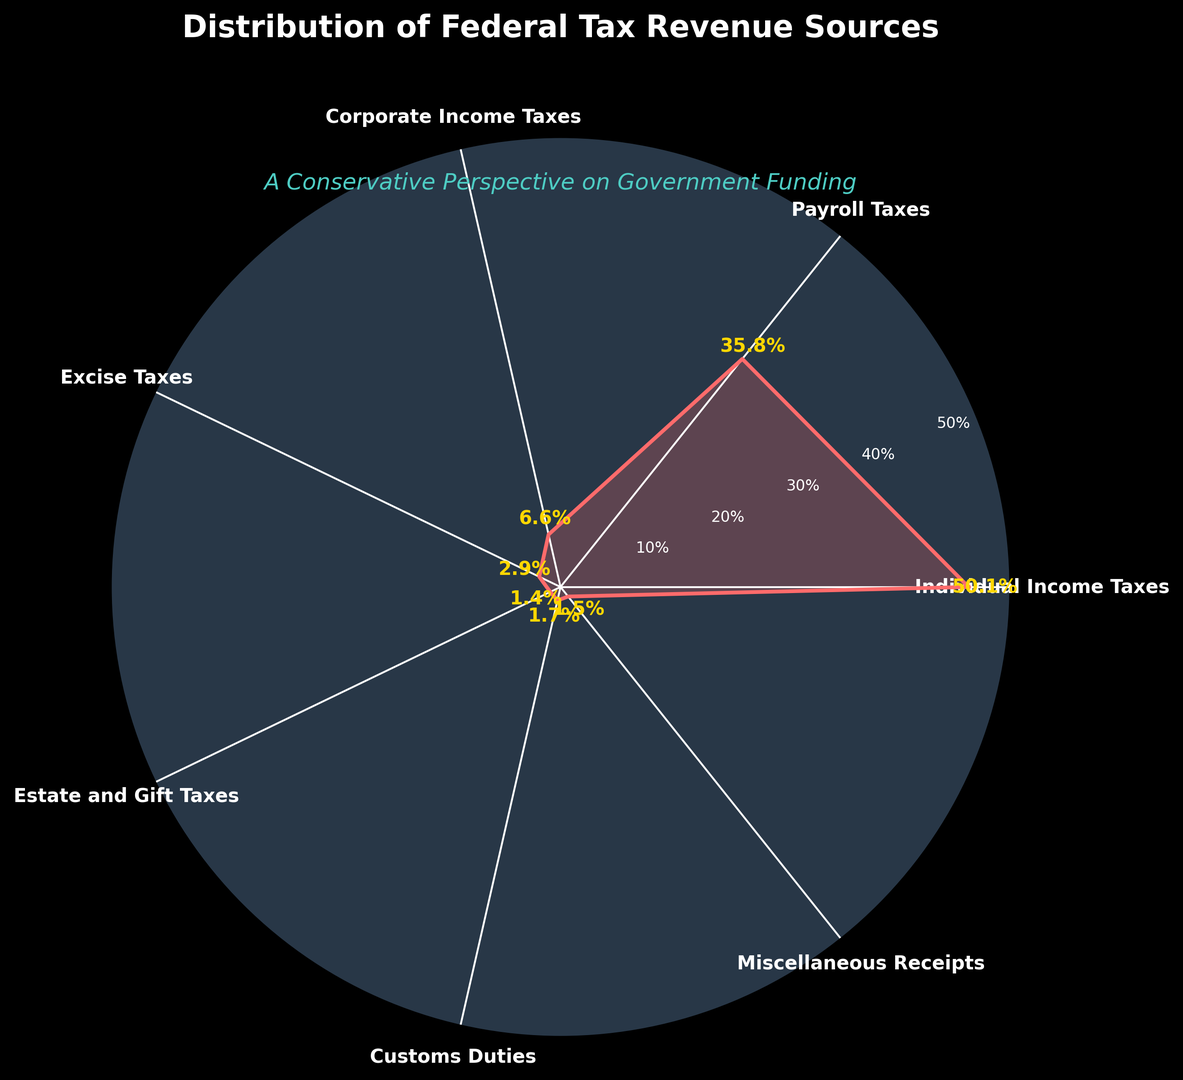What is the primary source of federal tax revenue? By looking at the chart, the section with the largest percentage should be identified as the primary source. The largest percentage is 50.1% which corresponds to Individual Income Taxes.
Answer: Individual Income Taxes Which tax revenue source accounts for a smaller percentage: Corporate Income Taxes or Excise Taxes? The chart shows that Corporate Income Taxes account for 6.6% and Excise Taxes account for 2.9%. Comparing these two, 2.9% is smaller than 6.6%.
Answer: Excise Taxes What is the combined percentage of Payroll Taxes and Customs Duties? According to the chart, Payroll Taxes account for 35.8% and Customs Duties account for 1.7%. Adding these two percentages gives 35.8 + 1.7 = 37.5%.
Answer: 37.5% Which tax revenue source contributes more, Excise Taxes or Miscellaneous Receipts? The chart shows that Excise Taxes contribute 2.9% and Miscellaneous Receipts contribute 1.5%. Comparing these two, 2.9% is greater than 1.5%.
Answer: Excise Taxes What is the sum of the percentages for Estate and Gift Taxes and Corporate Income Taxes? According to the chart, Estate and Gift Taxes account for 1.4% and Corporate Income Taxes account for 6.6%. Adding these two percentages gives 1.4 + 6.6 = 8.0%.
Answer: 8.0% How much more significant is the percentage of Individual Income Taxes compared to Corporate Income Taxes? The chart shows that Individual Income Taxes account for 50.1% and Corporate Income Taxes for 6.6%. The difference is 50.1 - 6.6 = 43.5%.
Answer: 43.5% Which two tax categories together account for almost the same percentage as Individual Income Taxes alone? Individual Income Taxes account for 50.1%. Looking at the chart, Payroll Taxes (35.8%) and Corporate Income Taxes (6.6%) together give 35.8 + 6.6 = 42.4%, which is not close enough. On combining Payroll Taxes (35.8%) and Excise Taxes (2.9%), we get 35.8 + 2.9 = 38.7%, which is still quite far. Payroll Taxes (35.8%) and Estate and Gift Taxes (1.4%) give 35.8 + 1.4 = 37.2%, which is also far. Finally, Payroll Taxes (35.8%) and Customs Duties (1.7%) give 35.8 + 1.7 = 37.5%, which is the closest significant combination, but only Miscellaneous Receipts (1.5%) and Excise Taxes (2.9%) give closer at 4.4%. Therefore, the two tax categories adding up closest significantly are Payroll Taxes and Customs Duties at 37.5%.
Answer: Payroll Taxes and Customs Duties 